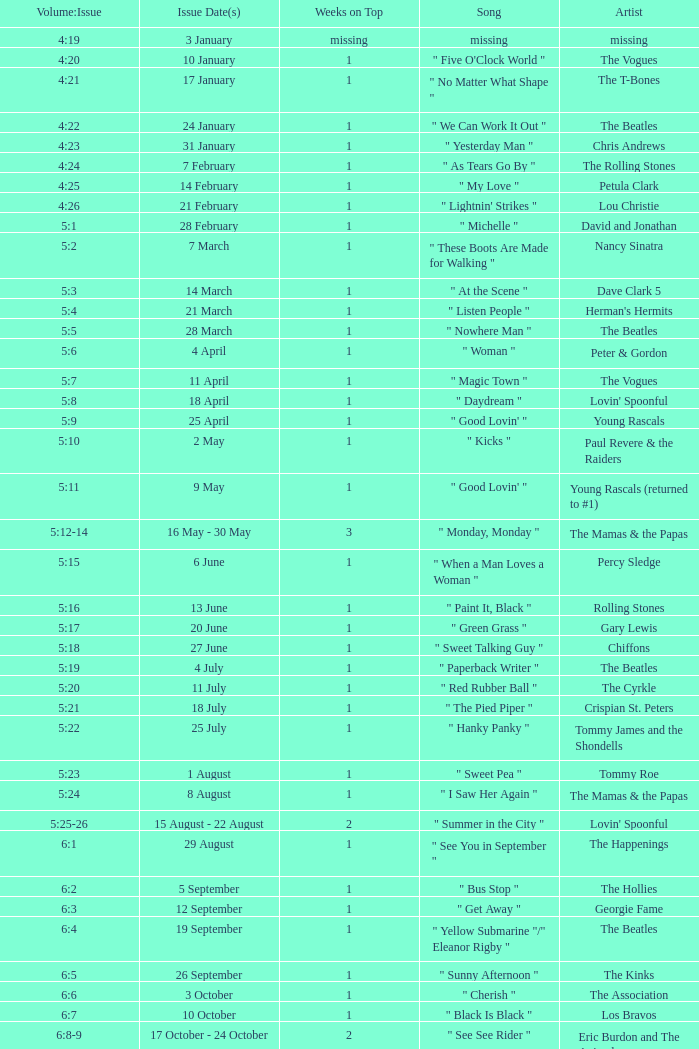In the 5:16 volume:issue, what is the name of the song listed? " Paint It, Black ". 